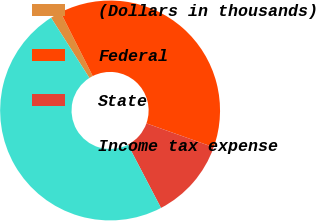Convert chart to OTSL. <chart><loc_0><loc_0><loc_500><loc_500><pie_chart><fcel>(Dollars in thousands)<fcel>Federal<fcel>State<fcel>Income tax expense<nl><fcel>1.59%<fcel>37.86%<fcel>11.91%<fcel>48.64%<nl></chart> 